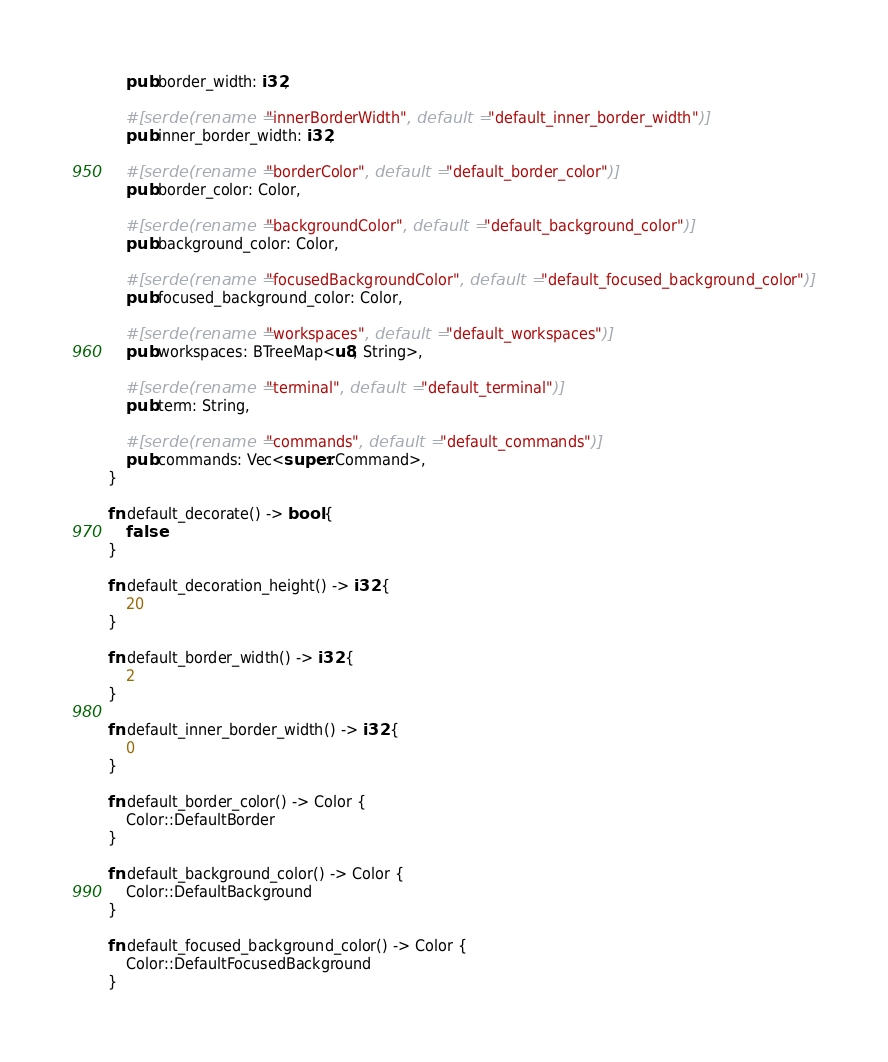<code> <loc_0><loc_0><loc_500><loc_500><_Rust_>    pub border_width: i32,

    #[serde(rename = "innerBorderWidth", default = "default_inner_border_width")]
    pub inner_border_width: i32,

    #[serde(rename = "borderColor", default = "default_border_color")]
    pub border_color: Color,

    #[serde(rename = "backgroundColor", default = "default_background_color")]
    pub background_color: Color,

    #[serde(rename = "focusedBackgroundColor", default = "default_focused_background_color")]
    pub focused_background_color: Color,

    #[serde(rename = "workspaces", default = "default_workspaces")]
    pub workspaces: BTreeMap<u8, String>,

    #[serde(rename = "terminal", default = "default_terminal")]
    pub term: String,

    #[serde(rename = "commands", default = "default_commands")]
    pub commands: Vec<super::Command>,
}

fn default_decorate() -> bool {
    false
}

fn default_decoration_height() -> i32 {
    20
}

fn default_border_width() -> i32 {
    2
}

fn default_inner_border_width() -> i32 {
    0
}

fn default_border_color() -> Color {
    Color::DefaultBorder
}

fn default_background_color() -> Color {
    Color::DefaultBackground
}

fn default_focused_background_color() -> Color {
    Color::DefaultFocusedBackground
}
</code> 